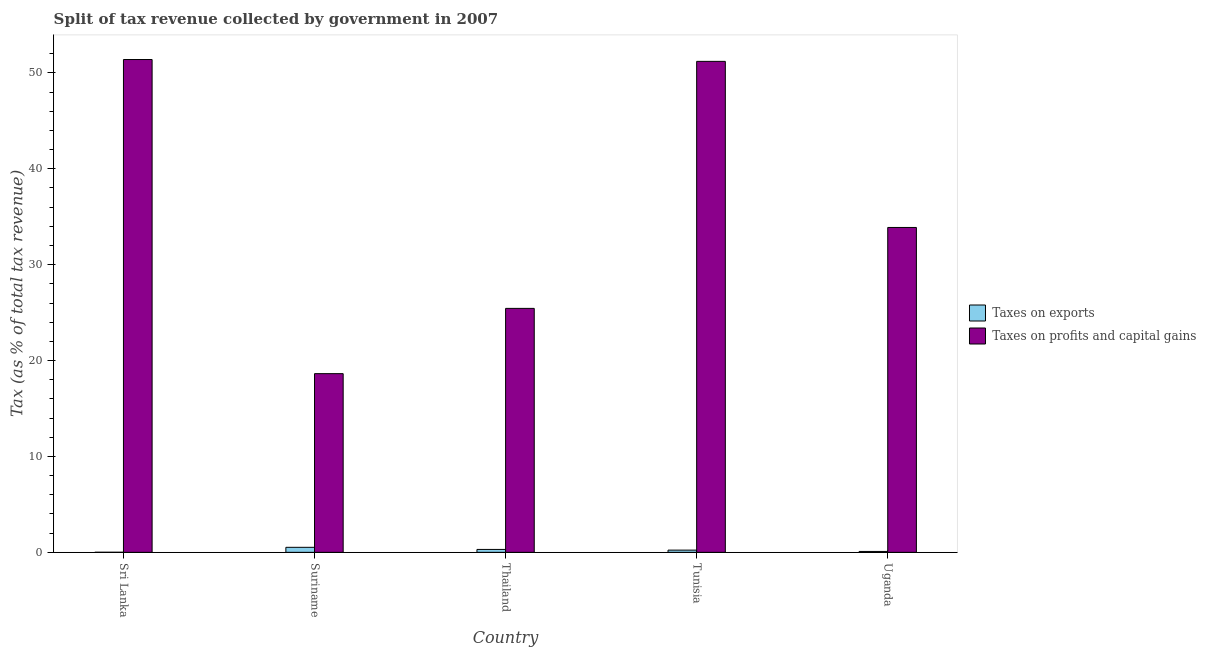Are the number of bars per tick equal to the number of legend labels?
Provide a succinct answer. Yes. Are the number of bars on each tick of the X-axis equal?
Provide a succinct answer. Yes. How many bars are there on the 1st tick from the left?
Your answer should be compact. 2. What is the label of the 2nd group of bars from the left?
Your response must be concise. Suriname. In how many cases, is the number of bars for a given country not equal to the number of legend labels?
Give a very brief answer. 0. What is the percentage of revenue obtained from taxes on exports in Tunisia?
Offer a terse response. 0.23. Across all countries, what is the maximum percentage of revenue obtained from taxes on exports?
Your response must be concise. 0.52. Across all countries, what is the minimum percentage of revenue obtained from taxes on profits and capital gains?
Your response must be concise. 18.63. In which country was the percentage of revenue obtained from taxes on profits and capital gains maximum?
Ensure brevity in your answer.  Sri Lanka. In which country was the percentage of revenue obtained from taxes on exports minimum?
Provide a succinct answer. Sri Lanka. What is the total percentage of revenue obtained from taxes on profits and capital gains in the graph?
Give a very brief answer. 180.55. What is the difference between the percentage of revenue obtained from taxes on exports in Thailand and that in Uganda?
Provide a succinct answer. 0.21. What is the difference between the percentage of revenue obtained from taxes on exports in Uganda and the percentage of revenue obtained from taxes on profits and capital gains in Sri Lanka?
Your answer should be very brief. -51.3. What is the average percentage of revenue obtained from taxes on profits and capital gains per country?
Your answer should be compact. 36.11. What is the difference between the percentage of revenue obtained from taxes on exports and percentage of revenue obtained from taxes on profits and capital gains in Sri Lanka?
Offer a terse response. -51.39. What is the ratio of the percentage of revenue obtained from taxes on exports in Tunisia to that in Uganda?
Provide a succinct answer. 2.51. Is the difference between the percentage of revenue obtained from taxes on exports in Suriname and Thailand greater than the difference between the percentage of revenue obtained from taxes on profits and capital gains in Suriname and Thailand?
Your answer should be very brief. Yes. What is the difference between the highest and the second highest percentage of revenue obtained from taxes on profits and capital gains?
Provide a short and direct response. 0.19. What is the difference between the highest and the lowest percentage of revenue obtained from taxes on profits and capital gains?
Make the answer very short. 32.76. In how many countries, is the percentage of revenue obtained from taxes on exports greater than the average percentage of revenue obtained from taxes on exports taken over all countries?
Your answer should be very brief. 3. Is the sum of the percentage of revenue obtained from taxes on profits and capital gains in Thailand and Uganda greater than the maximum percentage of revenue obtained from taxes on exports across all countries?
Provide a short and direct response. Yes. What does the 1st bar from the left in Suriname represents?
Offer a terse response. Taxes on exports. What does the 2nd bar from the right in Sri Lanka represents?
Ensure brevity in your answer.  Taxes on exports. How many bars are there?
Offer a very short reply. 10. Are all the bars in the graph horizontal?
Provide a succinct answer. No. Does the graph contain grids?
Provide a short and direct response. No. What is the title of the graph?
Your answer should be compact. Split of tax revenue collected by government in 2007. Does "Female labourers" appear as one of the legend labels in the graph?
Your answer should be very brief. No. What is the label or title of the Y-axis?
Provide a short and direct response. Tax (as % of total tax revenue). What is the Tax (as % of total tax revenue) of Taxes on exports in Sri Lanka?
Provide a short and direct response. 0.01. What is the Tax (as % of total tax revenue) of Taxes on profits and capital gains in Sri Lanka?
Offer a very short reply. 51.39. What is the Tax (as % of total tax revenue) in Taxes on exports in Suriname?
Your answer should be very brief. 0.52. What is the Tax (as % of total tax revenue) of Taxes on profits and capital gains in Suriname?
Your answer should be very brief. 18.63. What is the Tax (as % of total tax revenue) in Taxes on exports in Thailand?
Your answer should be very brief. 0.3. What is the Tax (as % of total tax revenue) of Taxes on profits and capital gains in Thailand?
Your answer should be very brief. 25.44. What is the Tax (as % of total tax revenue) of Taxes on exports in Tunisia?
Your answer should be very brief. 0.23. What is the Tax (as % of total tax revenue) in Taxes on profits and capital gains in Tunisia?
Give a very brief answer. 51.2. What is the Tax (as % of total tax revenue) of Taxes on exports in Uganda?
Your answer should be very brief. 0.09. What is the Tax (as % of total tax revenue) in Taxes on profits and capital gains in Uganda?
Your answer should be very brief. 33.88. Across all countries, what is the maximum Tax (as % of total tax revenue) in Taxes on exports?
Keep it short and to the point. 0.52. Across all countries, what is the maximum Tax (as % of total tax revenue) of Taxes on profits and capital gains?
Keep it short and to the point. 51.39. Across all countries, what is the minimum Tax (as % of total tax revenue) of Taxes on exports?
Keep it short and to the point. 0.01. Across all countries, what is the minimum Tax (as % of total tax revenue) in Taxes on profits and capital gains?
Offer a very short reply. 18.63. What is the total Tax (as % of total tax revenue) of Taxes on exports in the graph?
Keep it short and to the point. 1.16. What is the total Tax (as % of total tax revenue) of Taxes on profits and capital gains in the graph?
Ensure brevity in your answer.  180.55. What is the difference between the Tax (as % of total tax revenue) in Taxes on exports in Sri Lanka and that in Suriname?
Offer a terse response. -0.52. What is the difference between the Tax (as % of total tax revenue) of Taxes on profits and capital gains in Sri Lanka and that in Suriname?
Your answer should be very brief. 32.76. What is the difference between the Tax (as % of total tax revenue) of Taxes on exports in Sri Lanka and that in Thailand?
Your response must be concise. -0.3. What is the difference between the Tax (as % of total tax revenue) of Taxes on profits and capital gains in Sri Lanka and that in Thailand?
Provide a succinct answer. 25.95. What is the difference between the Tax (as % of total tax revenue) in Taxes on exports in Sri Lanka and that in Tunisia?
Your answer should be very brief. -0.23. What is the difference between the Tax (as % of total tax revenue) in Taxes on profits and capital gains in Sri Lanka and that in Tunisia?
Provide a short and direct response. 0.19. What is the difference between the Tax (as % of total tax revenue) in Taxes on exports in Sri Lanka and that in Uganda?
Your answer should be compact. -0.09. What is the difference between the Tax (as % of total tax revenue) of Taxes on profits and capital gains in Sri Lanka and that in Uganda?
Ensure brevity in your answer.  17.51. What is the difference between the Tax (as % of total tax revenue) in Taxes on exports in Suriname and that in Thailand?
Keep it short and to the point. 0.22. What is the difference between the Tax (as % of total tax revenue) of Taxes on profits and capital gains in Suriname and that in Thailand?
Offer a terse response. -6.81. What is the difference between the Tax (as % of total tax revenue) in Taxes on exports in Suriname and that in Tunisia?
Your answer should be very brief. 0.29. What is the difference between the Tax (as % of total tax revenue) of Taxes on profits and capital gains in Suriname and that in Tunisia?
Offer a very short reply. -32.57. What is the difference between the Tax (as % of total tax revenue) in Taxes on exports in Suriname and that in Uganda?
Your answer should be compact. 0.43. What is the difference between the Tax (as % of total tax revenue) of Taxes on profits and capital gains in Suriname and that in Uganda?
Provide a succinct answer. -15.25. What is the difference between the Tax (as % of total tax revenue) in Taxes on exports in Thailand and that in Tunisia?
Keep it short and to the point. 0.07. What is the difference between the Tax (as % of total tax revenue) of Taxes on profits and capital gains in Thailand and that in Tunisia?
Your answer should be very brief. -25.76. What is the difference between the Tax (as % of total tax revenue) in Taxes on exports in Thailand and that in Uganda?
Give a very brief answer. 0.21. What is the difference between the Tax (as % of total tax revenue) of Taxes on profits and capital gains in Thailand and that in Uganda?
Your response must be concise. -8.44. What is the difference between the Tax (as % of total tax revenue) in Taxes on exports in Tunisia and that in Uganda?
Your response must be concise. 0.14. What is the difference between the Tax (as % of total tax revenue) in Taxes on profits and capital gains in Tunisia and that in Uganda?
Your response must be concise. 17.32. What is the difference between the Tax (as % of total tax revenue) in Taxes on exports in Sri Lanka and the Tax (as % of total tax revenue) in Taxes on profits and capital gains in Suriname?
Offer a very short reply. -18.63. What is the difference between the Tax (as % of total tax revenue) in Taxes on exports in Sri Lanka and the Tax (as % of total tax revenue) in Taxes on profits and capital gains in Thailand?
Your answer should be very brief. -25.43. What is the difference between the Tax (as % of total tax revenue) of Taxes on exports in Sri Lanka and the Tax (as % of total tax revenue) of Taxes on profits and capital gains in Tunisia?
Ensure brevity in your answer.  -51.19. What is the difference between the Tax (as % of total tax revenue) in Taxes on exports in Sri Lanka and the Tax (as % of total tax revenue) in Taxes on profits and capital gains in Uganda?
Offer a very short reply. -33.87. What is the difference between the Tax (as % of total tax revenue) in Taxes on exports in Suriname and the Tax (as % of total tax revenue) in Taxes on profits and capital gains in Thailand?
Provide a short and direct response. -24.92. What is the difference between the Tax (as % of total tax revenue) in Taxes on exports in Suriname and the Tax (as % of total tax revenue) in Taxes on profits and capital gains in Tunisia?
Provide a succinct answer. -50.68. What is the difference between the Tax (as % of total tax revenue) in Taxes on exports in Suriname and the Tax (as % of total tax revenue) in Taxes on profits and capital gains in Uganda?
Give a very brief answer. -33.36. What is the difference between the Tax (as % of total tax revenue) in Taxes on exports in Thailand and the Tax (as % of total tax revenue) in Taxes on profits and capital gains in Tunisia?
Offer a very short reply. -50.9. What is the difference between the Tax (as % of total tax revenue) of Taxes on exports in Thailand and the Tax (as % of total tax revenue) of Taxes on profits and capital gains in Uganda?
Make the answer very short. -33.58. What is the difference between the Tax (as % of total tax revenue) in Taxes on exports in Tunisia and the Tax (as % of total tax revenue) in Taxes on profits and capital gains in Uganda?
Provide a succinct answer. -33.65. What is the average Tax (as % of total tax revenue) of Taxes on exports per country?
Provide a succinct answer. 0.23. What is the average Tax (as % of total tax revenue) in Taxes on profits and capital gains per country?
Your answer should be compact. 36.11. What is the difference between the Tax (as % of total tax revenue) of Taxes on exports and Tax (as % of total tax revenue) of Taxes on profits and capital gains in Sri Lanka?
Make the answer very short. -51.39. What is the difference between the Tax (as % of total tax revenue) in Taxes on exports and Tax (as % of total tax revenue) in Taxes on profits and capital gains in Suriname?
Offer a terse response. -18.11. What is the difference between the Tax (as % of total tax revenue) in Taxes on exports and Tax (as % of total tax revenue) in Taxes on profits and capital gains in Thailand?
Make the answer very short. -25.14. What is the difference between the Tax (as % of total tax revenue) in Taxes on exports and Tax (as % of total tax revenue) in Taxes on profits and capital gains in Tunisia?
Your answer should be compact. -50.97. What is the difference between the Tax (as % of total tax revenue) in Taxes on exports and Tax (as % of total tax revenue) in Taxes on profits and capital gains in Uganda?
Offer a terse response. -33.79. What is the ratio of the Tax (as % of total tax revenue) in Taxes on exports in Sri Lanka to that in Suriname?
Provide a short and direct response. 0.01. What is the ratio of the Tax (as % of total tax revenue) in Taxes on profits and capital gains in Sri Lanka to that in Suriname?
Make the answer very short. 2.76. What is the ratio of the Tax (as % of total tax revenue) in Taxes on exports in Sri Lanka to that in Thailand?
Provide a succinct answer. 0.02. What is the ratio of the Tax (as % of total tax revenue) in Taxes on profits and capital gains in Sri Lanka to that in Thailand?
Keep it short and to the point. 2.02. What is the ratio of the Tax (as % of total tax revenue) of Taxes on exports in Sri Lanka to that in Tunisia?
Your response must be concise. 0.03. What is the ratio of the Tax (as % of total tax revenue) of Taxes on exports in Sri Lanka to that in Uganda?
Your answer should be compact. 0.07. What is the ratio of the Tax (as % of total tax revenue) in Taxes on profits and capital gains in Sri Lanka to that in Uganda?
Your answer should be compact. 1.52. What is the ratio of the Tax (as % of total tax revenue) of Taxes on exports in Suriname to that in Thailand?
Provide a short and direct response. 1.73. What is the ratio of the Tax (as % of total tax revenue) in Taxes on profits and capital gains in Suriname to that in Thailand?
Make the answer very short. 0.73. What is the ratio of the Tax (as % of total tax revenue) of Taxes on exports in Suriname to that in Tunisia?
Your answer should be compact. 2.25. What is the ratio of the Tax (as % of total tax revenue) in Taxes on profits and capital gains in Suriname to that in Tunisia?
Your answer should be compact. 0.36. What is the ratio of the Tax (as % of total tax revenue) of Taxes on exports in Suriname to that in Uganda?
Your response must be concise. 5.64. What is the ratio of the Tax (as % of total tax revenue) in Taxes on profits and capital gains in Suriname to that in Uganda?
Keep it short and to the point. 0.55. What is the ratio of the Tax (as % of total tax revenue) in Taxes on exports in Thailand to that in Tunisia?
Keep it short and to the point. 1.3. What is the ratio of the Tax (as % of total tax revenue) in Taxes on profits and capital gains in Thailand to that in Tunisia?
Give a very brief answer. 0.5. What is the ratio of the Tax (as % of total tax revenue) of Taxes on exports in Thailand to that in Uganda?
Your answer should be very brief. 3.27. What is the ratio of the Tax (as % of total tax revenue) in Taxes on profits and capital gains in Thailand to that in Uganda?
Keep it short and to the point. 0.75. What is the ratio of the Tax (as % of total tax revenue) of Taxes on exports in Tunisia to that in Uganda?
Make the answer very short. 2.51. What is the ratio of the Tax (as % of total tax revenue) of Taxes on profits and capital gains in Tunisia to that in Uganda?
Your answer should be very brief. 1.51. What is the difference between the highest and the second highest Tax (as % of total tax revenue) of Taxes on exports?
Provide a succinct answer. 0.22. What is the difference between the highest and the second highest Tax (as % of total tax revenue) in Taxes on profits and capital gains?
Your answer should be very brief. 0.19. What is the difference between the highest and the lowest Tax (as % of total tax revenue) in Taxes on exports?
Give a very brief answer. 0.52. What is the difference between the highest and the lowest Tax (as % of total tax revenue) in Taxes on profits and capital gains?
Your answer should be compact. 32.76. 